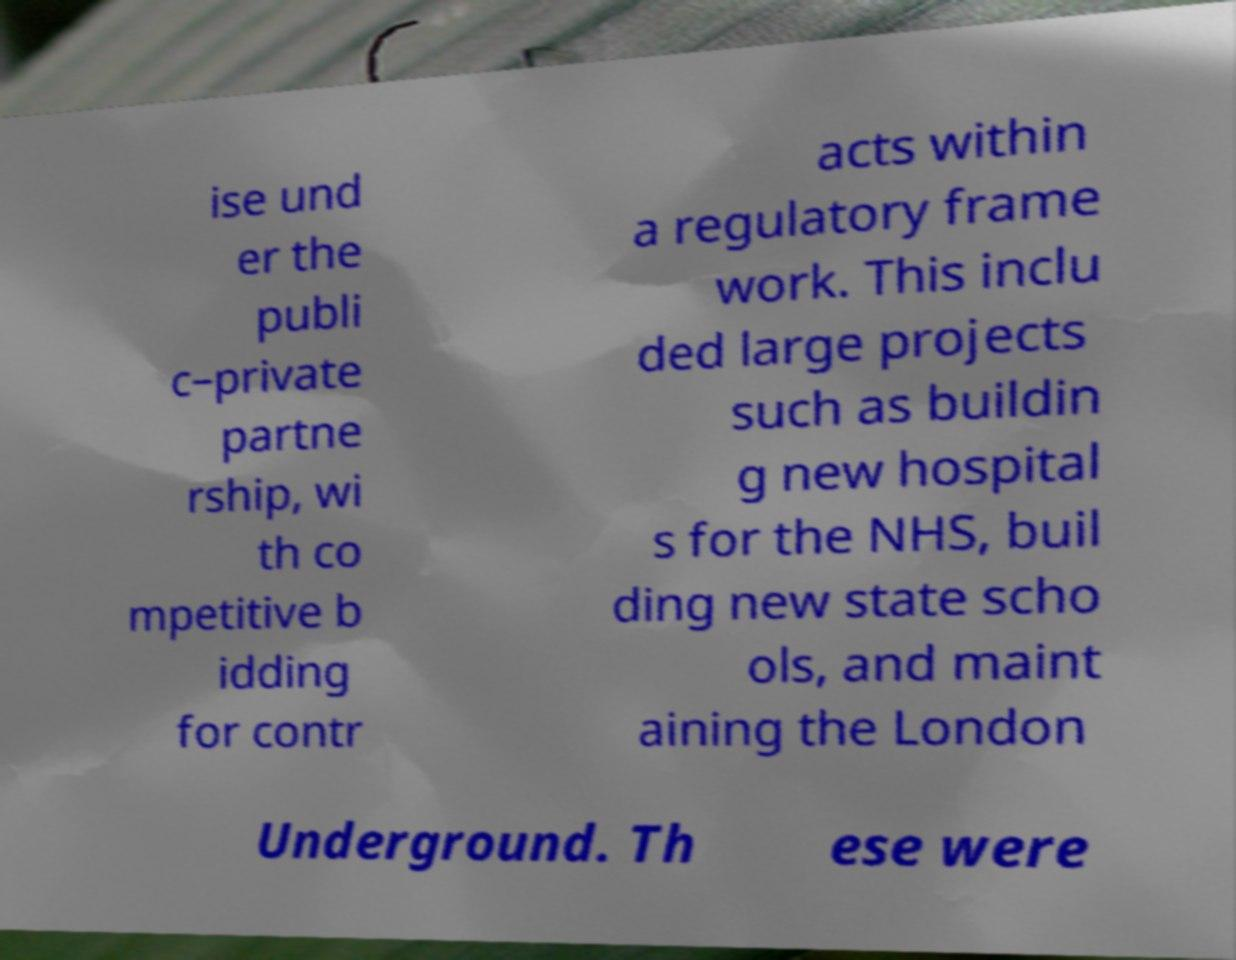Please identify and transcribe the text found in this image. ise und er the publi c–private partne rship, wi th co mpetitive b idding for contr acts within a regulatory frame work. This inclu ded large projects such as buildin g new hospital s for the NHS, buil ding new state scho ols, and maint aining the London Underground. Th ese were 